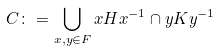<formula> <loc_0><loc_0><loc_500><loc_500>C \colon = \bigcup _ { x , y \in F } x H x ^ { - 1 } \cap y K y ^ { - 1 }</formula> 